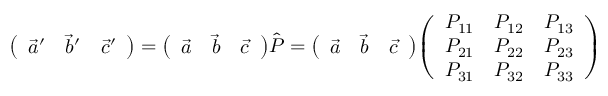<formula> <loc_0><loc_0><loc_500><loc_500>{ \left ( \begin{array} { l l l } { { \vec { a } } ^ { \prime } } & { { \vec { b } } ^ { \prime } } & { { \vec { c } } ^ { \prime } } \end{array} \right ) } = { \left ( \begin{array} { l l l } { { \vec { a } } } & { { \vec { b } } } & { { \vec { c } } } \end{array} \right ) } { \hat { P } } = { \left ( \begin{array} { l l l } { { \vec { a } } } & { { \vec { b } } } & { { \vec { c } } } \end{array} \right ) } { \left ( \begin{array} { l l l } { P _ { 1 1 } } & { P _ { 1 2 } } & { P _ { 1 3 } } \\ { P _ { 2 1 } } & { P _ { 2 2 } } & { P _ { 2 3 } } \\ { P _ { 3 1 } } & { P _ { 3 2 } } & { P _ { 3 3 } } \end{array} \right ) }</formula> 